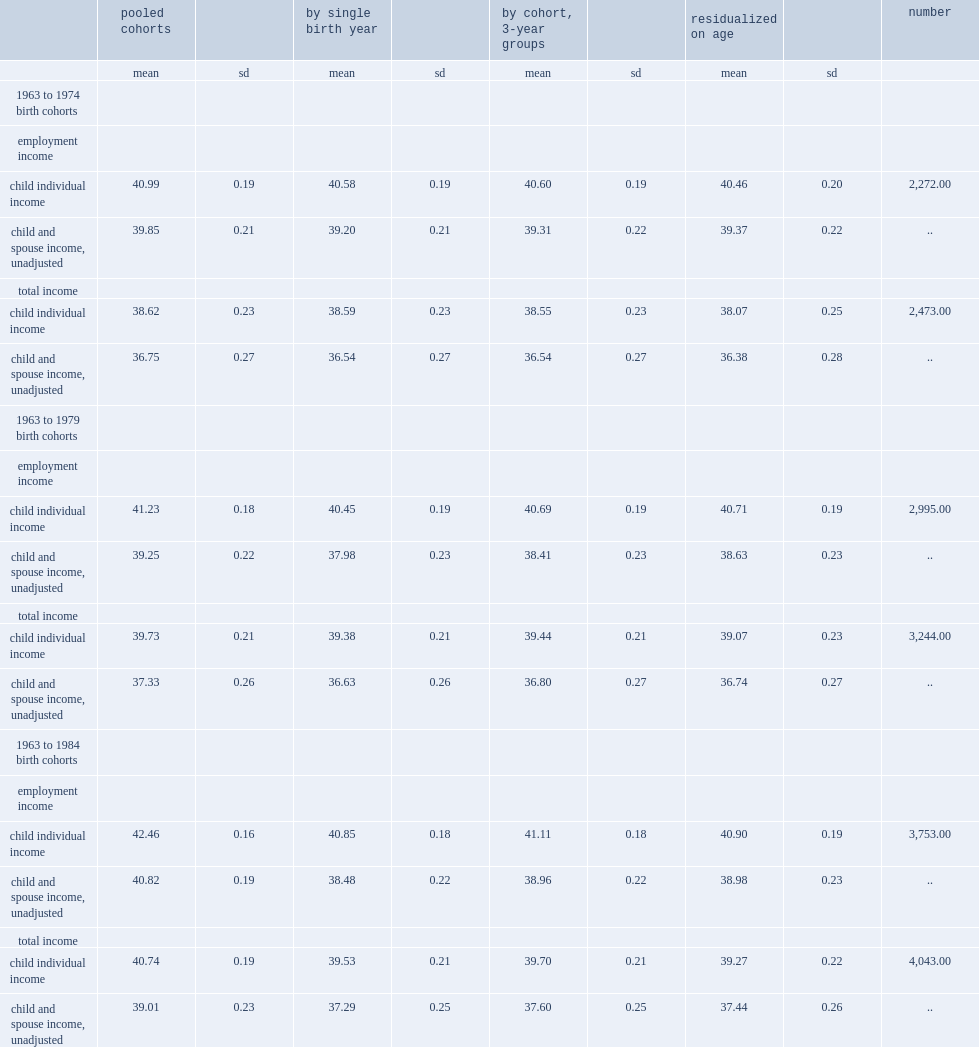How many times the sample size of the 1963-1984 cohorts is that of the 1963-1974 cohorts when using total income? 1.634856. 